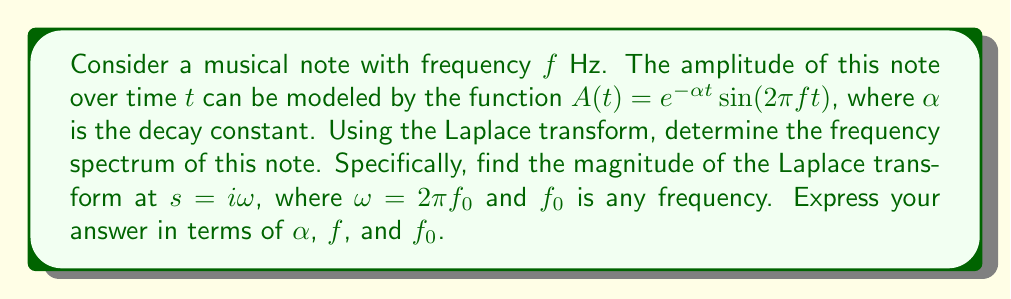Teach me how to tackle this problem. Let's approach this step-by-step:

1) The Laplace transform of $A(t)$ is given by:

   $$\mathcal{L}\{A(t)\} = \int_0^\infty e^{-\alpha t} \sin(2\pi f t) e^{-st} dt$$

2) We can rewrite this using Euler's formula:

   $$\sin(2\pi f t) = \frac{e^{i2\pi f t} - e^{-i2\pi f t}}{2i}$$

3) Substituting this in:

   $$\mathcal{L}\{A(t)\} = \frac{1}{2i} \int_0^\infty e^{-\alpha t} (e^{i2\pi f t} - e^{-i2\pi f t}) e^{-st} dt$$

4) This can be separated into two integrals:

   $$\mathcal{L}\{A(t)\} = \frac{1}{2i} \left(\int_0^\infty e^{-(s+\alpha-i2\pi f)t} dt - \int_0^\infty e^{-(s+\alpha+i2\pi f)t} dt\right)$$

5) Evaluating these integrals:

   $$\mathcal{L}\{A(t)\} = \frac{1}{2i} \left(\frac{1}{s+\alpha-i2\pi f} - \frac{1}{s+\alpha+i2\pi f}\right)$$

6) Now, we want to evaluate this at $s = i\omega = i2\pi f_0$:

   $$\mathcal{L}\{A(t)\}_{s=i2\pi f_0} = \frac{1}{2i} \left(\frac{1}{i2\pi f_0+\alpha-i2\pi f} - \frac{1}{i2\pi f_0+\alpha+i2\pi f}\right)$$

7) Simplifying:

   $$\mathcal{L}\{A(t)\}_{s=i2\pi f_0} = \frac{1}{2i} \left(\frac{1}{\alpha+i2\pi(f_0-f)} - \frac{1}{\alpha+i2\pi(f_0+f)}\right)$$

8) To find the magnitude, we multiply by the complex conjugate:

   $$|\mathcal{L}\{A(t)\}_{s=i2\pi f_0}| = \frac{1}{2} \sqrt{\frac{1}{\alpha^2+4\pi^2(f_0-f)^2} + \frac{1}{\alpha^2+4\pi^2(f_0+f)^2}}$$

This expression gives the magnitude of the frequency spectrum at any frequency $f_0$.
Answer: $$|\mathcal{L}\{A(t)\}_{s=i2\pi f_0}| = \frac{1}{2} \sqrt{\frac{1}{\alpha^2+4\pi^2(f_0-f)^2} + \frac{1}{\alpha^2+4\pi^2(f_0+f)^2}}$$ 